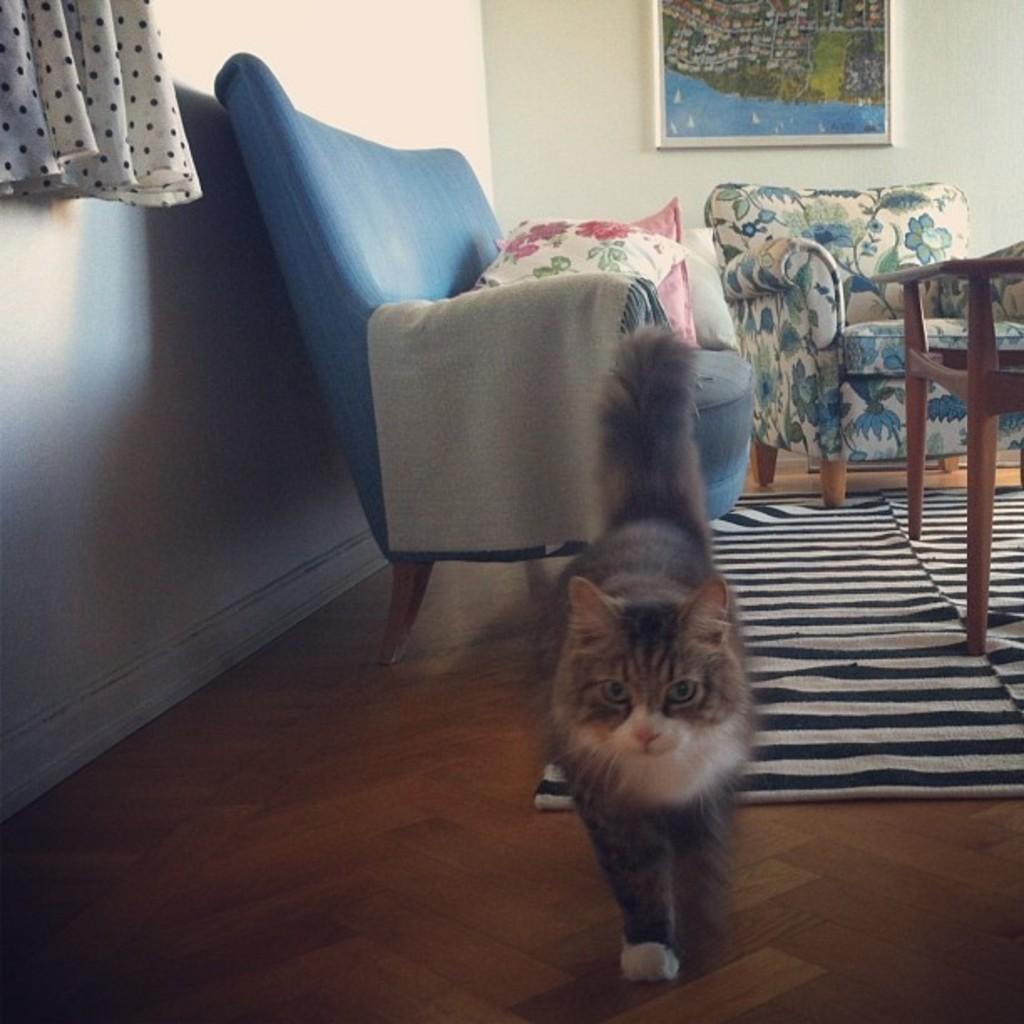How would you summarize this image in a sentence or two? In this picture we can see a cat and in the background there is a couch with some pillows, there is a sofa here a table and a wall with photo frame and we can see a curtain 